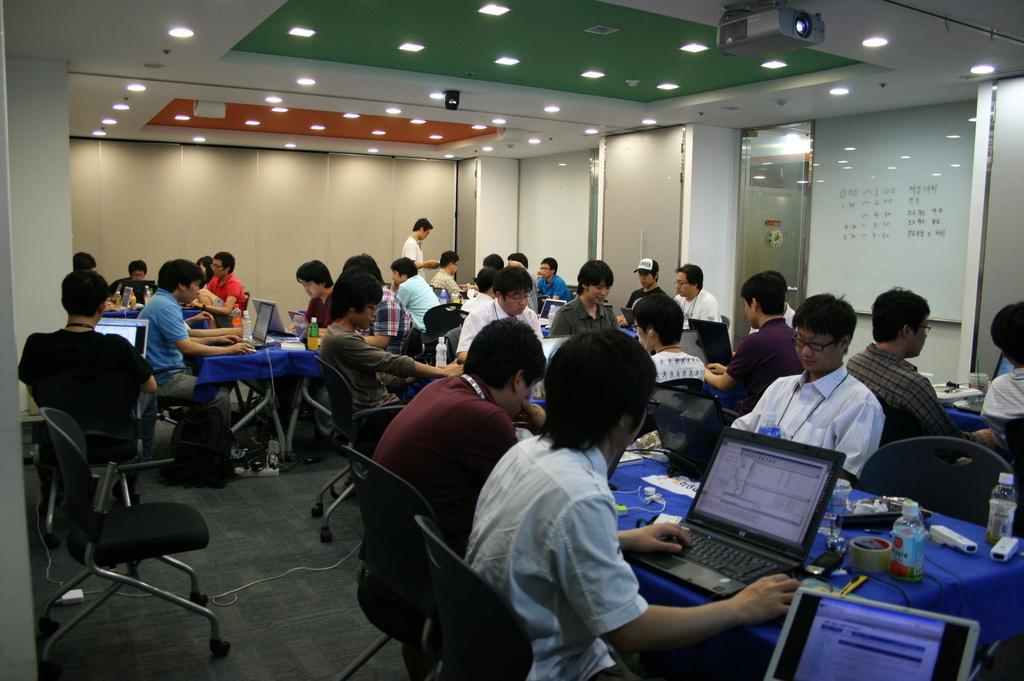Can you describe this image briefly? In this image we can see few people sitting on the chairs, a person is standing and some people are working on the laptops, there are few tables covered with clothes and few objects on the table, there is a board with text on the wall and there are few lights and a projector to the ceiling. 